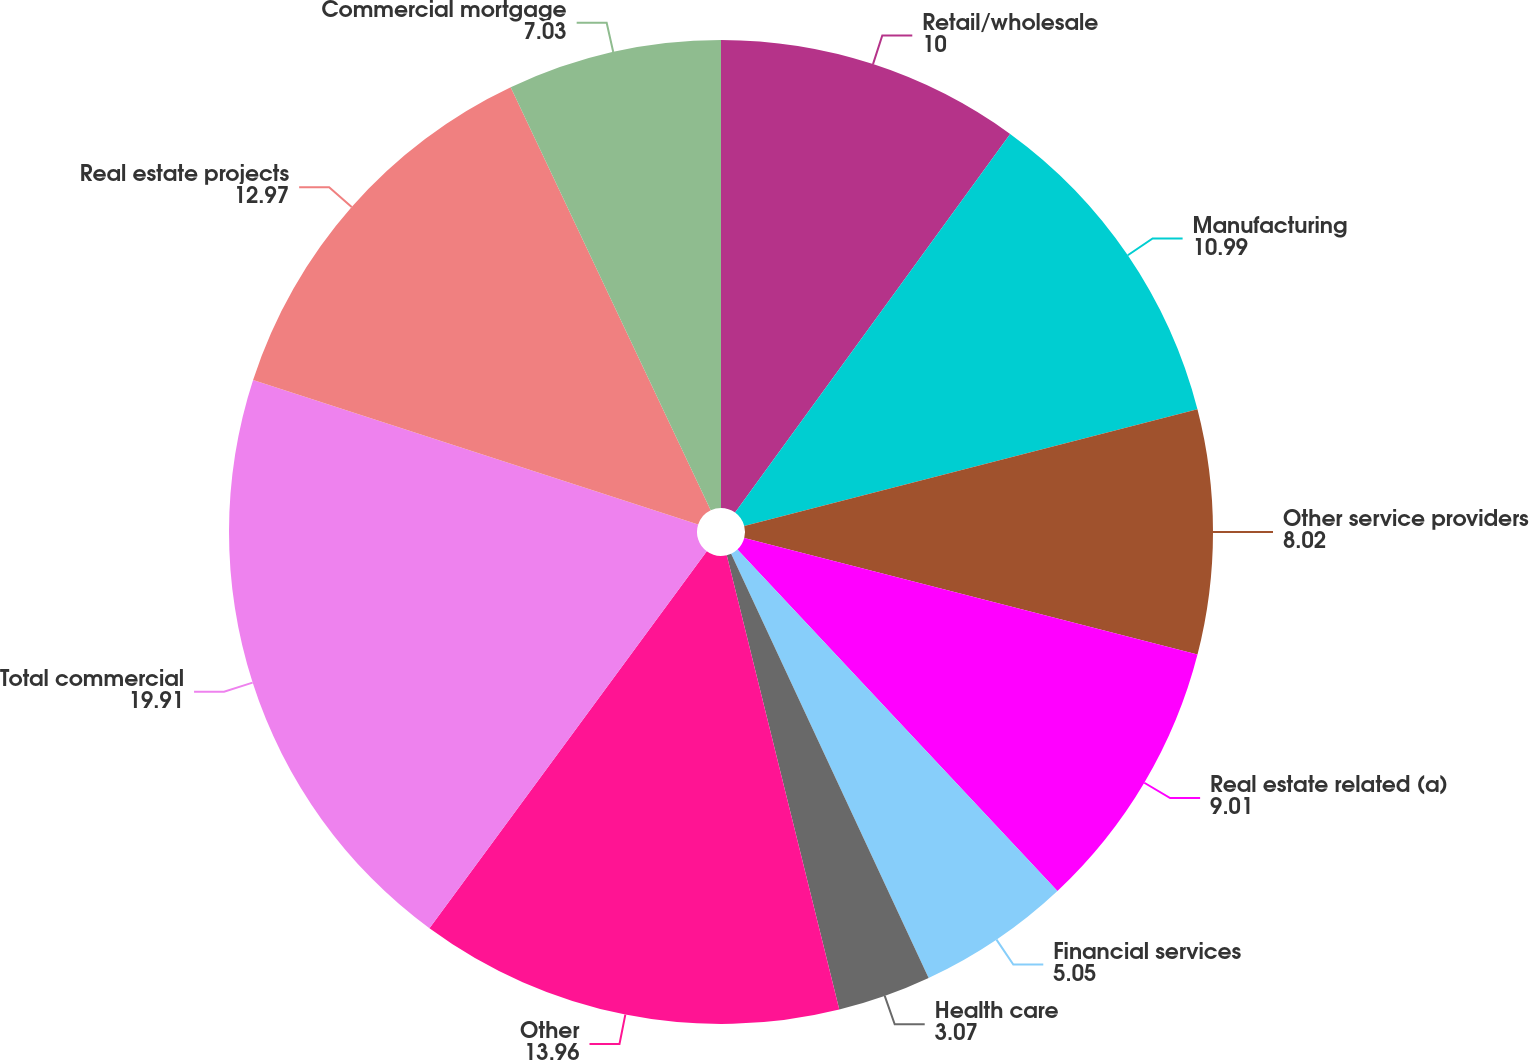Convert chart to OTSL. <chart><loc_0><loc_0><loc_500><loc_500><pie_chart><fcel>Retail/wholesale<fcel>Manufacturing<fcel>Other service providers<fcel>Real estate related (a)<fcel>Financial services<fcel>Health care<fcel>Other<fcel>Total commercial<fcel>Real estate projects<fcel>Commercial mortgage<nl><fcel>10.0%<fcel>10.99%<fcel>8.02%<fcel>9.01%<fcel>5.05%<fcel>3.07%<fcel>13.96%<fcel>19.91%<fcel>12.97%<fcel>7.03%<nl></chart> 